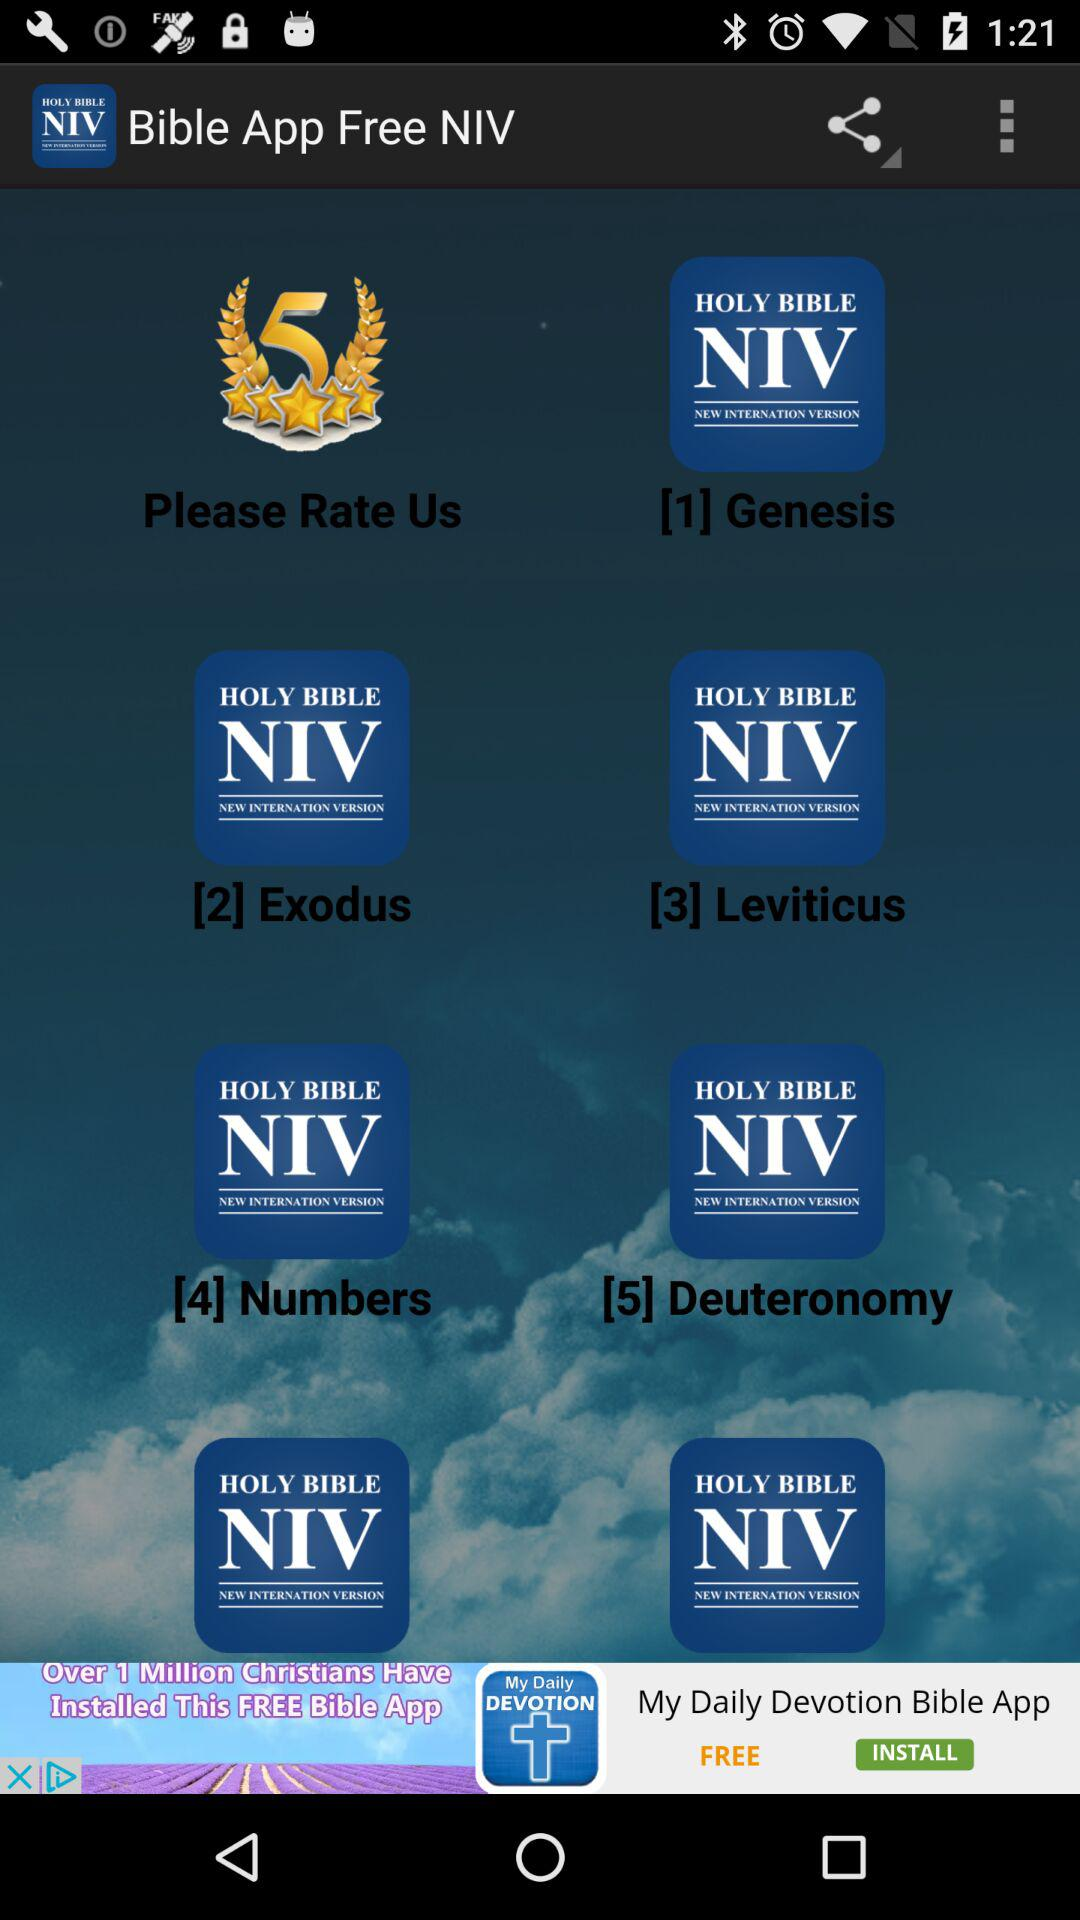What is the application name? The application name is "Bible App Free NIV". 